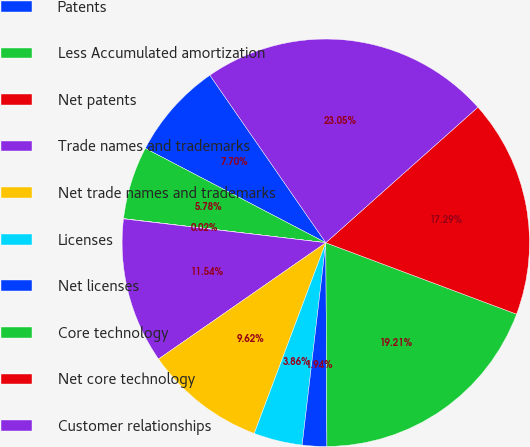Convert chart. <chart><loc_0><loc_0><loc_500><loc_500><pie_chart><fcel>Patents<fcel>Less Accumulated amortization<fcel>Net patents<fcel>Trade names and trademarks<fcel>Net trade names and trademarks<fcel>Licenses<fcel>Net licenses<fcel>Core technology<fcel>Net core technology<fcel>Customer relationships<nl><fcel>7.7%<fcel>5.78%<fcel>0.02%<fcel>11.54%<fcel>9.62%<fcel>3.86%<fcel>1.94%<fcel>19.21%<fcel>17.29%<fcel>23.05%<nl></chart> 